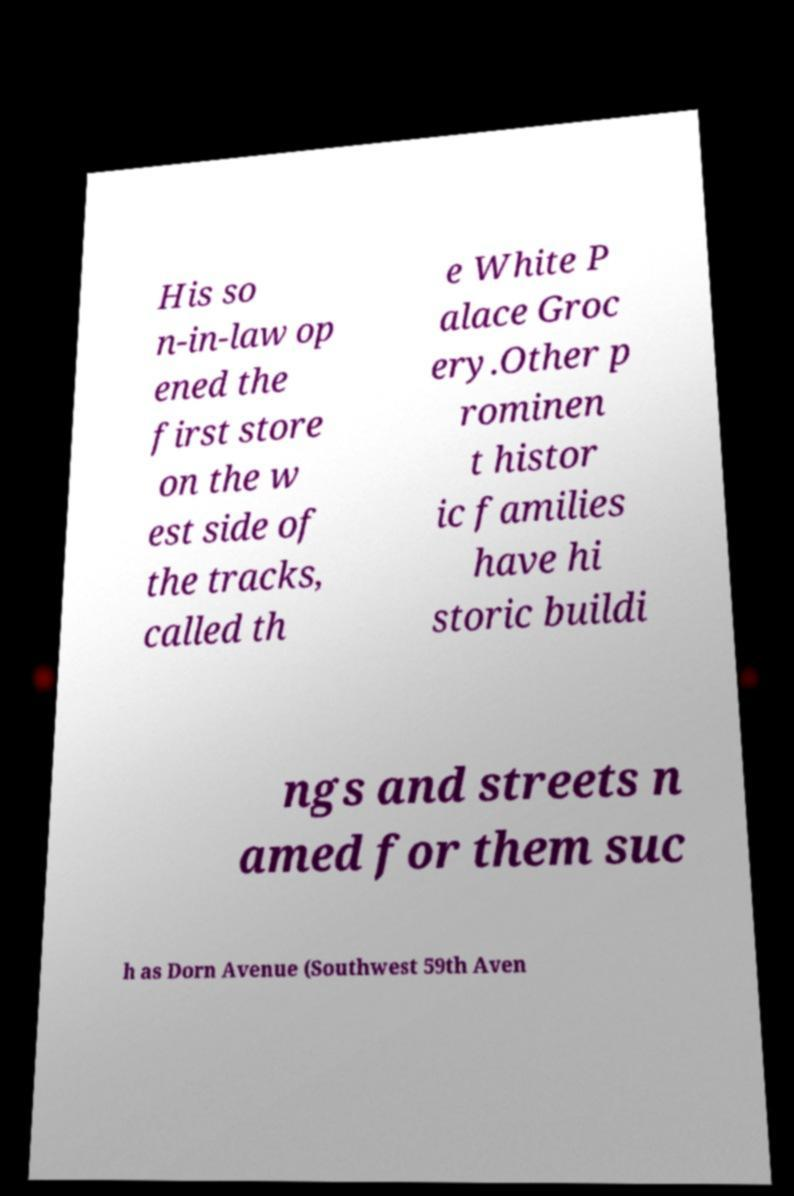Can you accurately transcribe the text from the provided image for me? His so n-in-law op ened the first store on the w est side of the tracks, called th e White P alace Groc ery.Other p rominen t histor ic families have hi storic buildi ngs and streets n amed for them suc h as Dorn Avenue (Southwest 59th Aven 